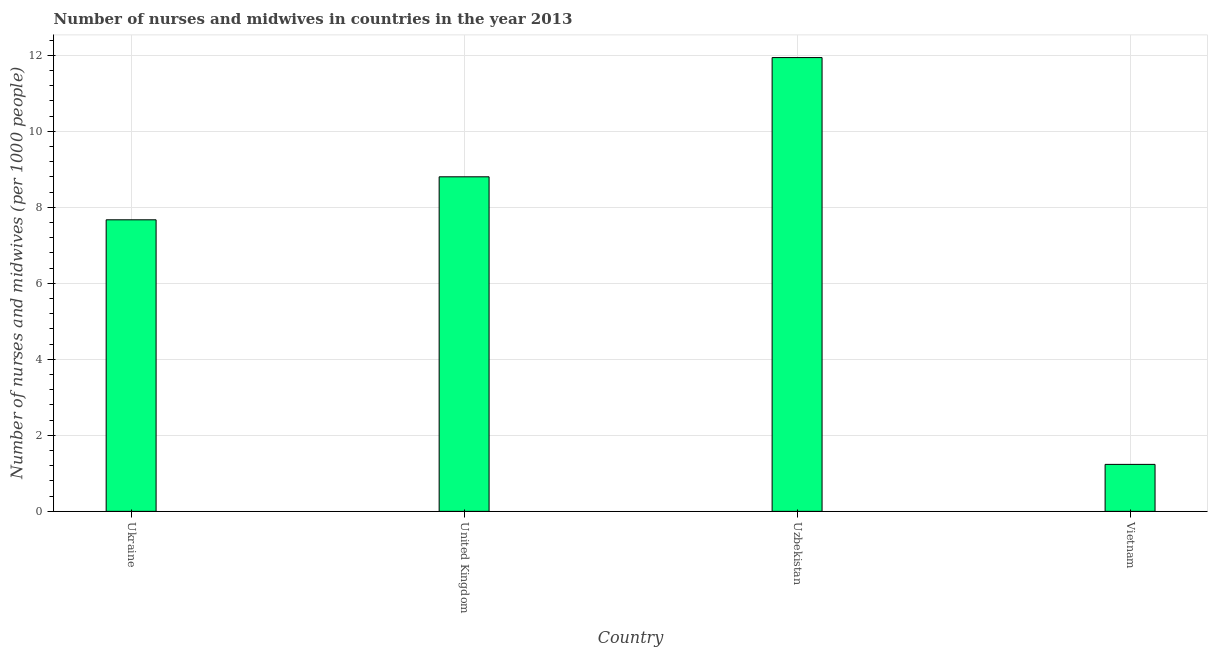Does the graph contain grids?
Keep it short and to the point. Yes. What is the title of the graph?
Ensure brevity in your answer.  Number of nurses and midwives in countries in the year 2013. What is the label or title of the X-axis?
Ensure brevity in your answer.  Country. What is the label or title of the Y-axis?
Offer a terse response. Number of nurses and midwives (per 1000 people). What is the number of nurses and midwives in Vietnam?
Make the answer very short. 1.24. Across all countries, what is the maximum number of nurses and midwives?
Offer a very short reply. 11.94. Across all countries, what is the minimum number of nurses and midwives?
Ensure brevity in your answer.  1.24. In which country was the number of nurses and midwives maximum?
Provide a succinct answer. Uzbekistan. In which country was the number of nurses and midwives minimum?
Your answer should be very brief. Vietnam. What is the sum of the number of nurses and midwives?
Your response must be concise. 29.64. What is the difference between the number of nurses and midwives in United Kingdom and Vietnam?
Offer a terse response. 7.57. What is the average number of nurses and midwives per country?
Provide a short and direct response. 7.41. What is the median number of nurses and midwives?
Keep it short and to the point. 8.24. In how many countries, is the number of nurses and midwives greater than 2 ?
Your answer should be very brief. 3. What is the ratio of the number of nurses and midwives in Uzbekistan to that in Vietnam?
Offer a terse response. 9.66. Is the number of nurses and midwives in Ukraine less than that in Uzbekistan?
Keep it short and to the point. Yes. Is the difference between the number of nurses and midwives in United Kingdom and Vietnam greater than the difference between any two countries?
Offer a terse response. No. What is the difference between the highest and the second highest number of nurses and midwives?
Give a very brief answer. 3.14. In how many countries, is the number of nurses and midwives greater than the average number of nurses and midwives taken over all countries?
Give a very brief answer. 3. How many bars are there?
Your answer should be compact. 4. Are all the bars in the graph horizontal?
Provide a succinct answer. No. How many countries are there in the graph?
Provide a short and direct response. 4. What is the Number of nurses and midwives (per 1000 people) of Ukraine?
Provide a short and direct response. 7.67. What is the Number of nurses and midwives (per 1000 people) in United Kingdom?
Your answer should be very brief. 8.8. What is the Number of nurses and midwives (per 1000 people) in Uzbekistan?
Your answer should be compact. 11.94. What is the Number of nurses and midwives (per 1000 people) in Vietnam?
Keep it short and to the point. 1.24. What is the difference between the Number of nurses and midwives (per 1000 people) in Ukraine and United Kingdom?
Keep it short and to the point. -1.13. What is the difference between the Number of nurses and midwives (per 1000 people) in Ukraine and Uzbekistan?
Provide a short and direct response. -4.27. What is the difference between the Number of nurses and midwives (per 1000 people) in Ukraine and Vietnam?
Provide a succinct answer. 6.43. What is the difference between the Number of nurses and midwives (per 1000 people) in United Kingdom and Uzbekistan?
Your answer should be very brief. -3.14. What is the difference between the Number of nurses and midwives (per 1000 people) in United Kingdom and Vietnam?
Offer a very short reply. 7.57. What is the difference between the Number of nurses and midwives (per 1000 people) in Uzbekistan and Vietnam?
Make the answer very short. 10.7. What is the ratio of the Number of nurses and midwives (per 1000 people) in Ukraine to that in United Kingdom?
Your answer should be very brief. 0.87. What is the ratio of the Number of nurses and midwives (per 1000 people) in Ukraine to that in Uzbekistan?
Ensure brevity in your answer.  0.64. What is the ratio of the Number of nurses and midwives (per 1000 people) in Ukraine to that in Vietnam?
Make the answer very short. 6.21. What is the ratio of the Number of nurses and midwives (per 1000 people) in United Kingdom to that in Uzbekistan?
Your response must be concise. 0.74. What is the ratio of the Number of nurses and midwives (per 1000 people) in United Kingdom to that in Vietnam?
Your answer should be compact. 7.12. What is the ratio of the Number of nurses and midwives (per 1000 people) in Uzbekistan to that in Vietnam?
Keep it short and to the point. 9.66. 